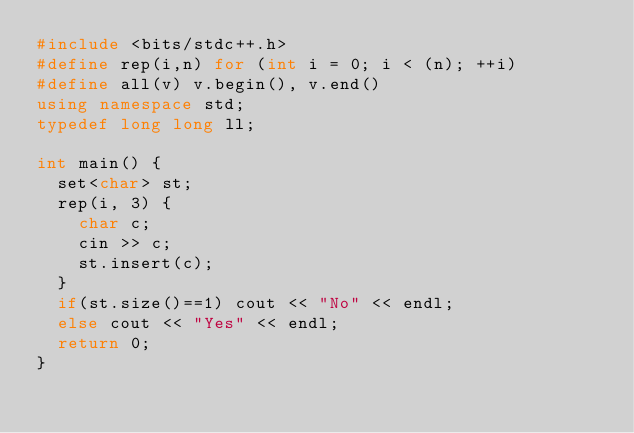Convert code to text. <code><loc_0><loc_0><loc_500><loc_500><_C++_>#include <bits/stdc++.h>
#define rep(i,n) for (int i = 0; i < (n); ++i)
#define all(v) v.begin(), v.end()
using namespace std;
typedef long long ll;

int main() {
	set<char> st;
	rep(i, 3) {
		char c;
		cin >> c;
		st.insert(c);
	}
	if(st.size()==1) cout << "No" << endl;
	else cout << "Yes" << endl;
	return 0;
}</code> 